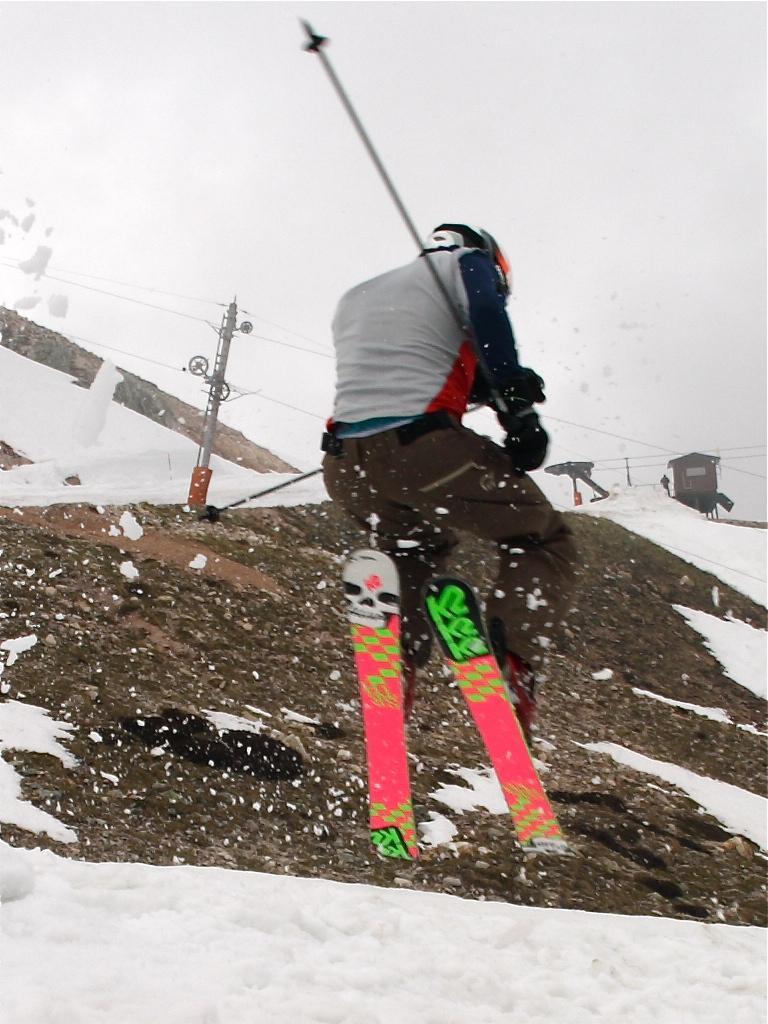In one or two sentences, can you explain what this image depicts? In this picture there is a person jumping with the skies. At the back there is a house and there poles and there is a person standing and there are wires on the poles. At the top there is sky. At the bottom there is snow and there is rock. 